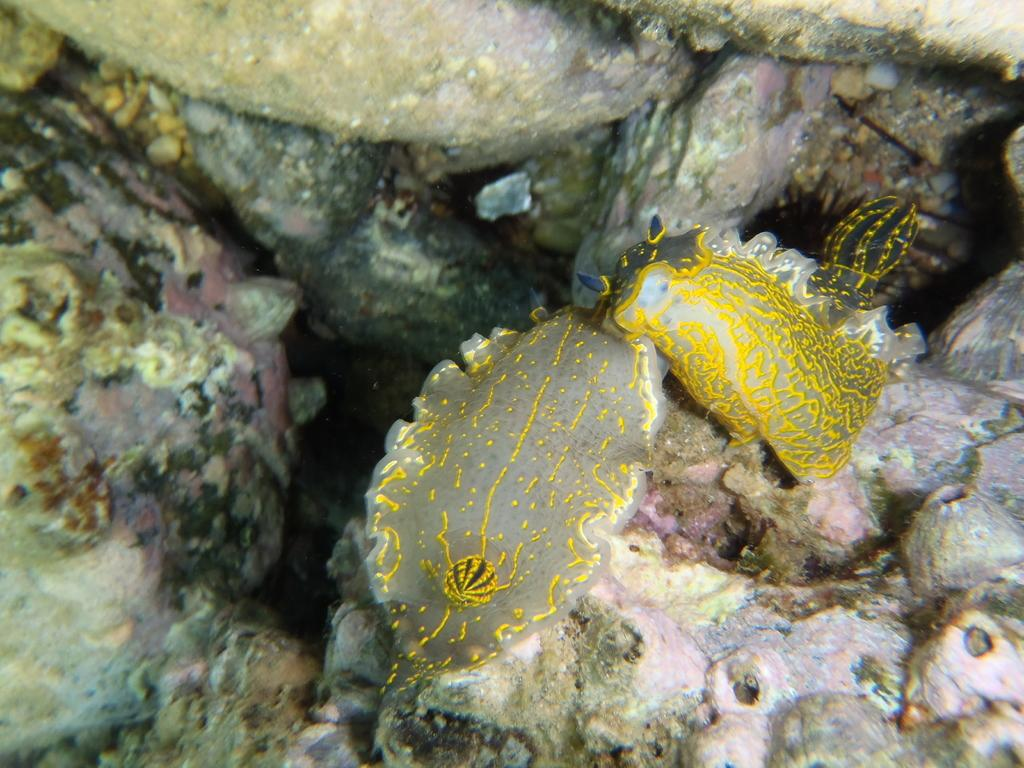What type of environment is depicted in the image? The image shows an underwater environment. What can be seen growing on the ocean floor? There are underwater corals in the image. What else can be found on the ocean floor besides corals? There are stones in the image. What kind of creatures inhabit this underwater environment? There are water animals in the image. What shape is the stomach of the underwater creature in the image? There are no underwater creatures with visible stomachs in the image. How many brothers are swimming with the water animals in the image? There are no people or human-like creatures depicted in the image, so there are no brothers present. 